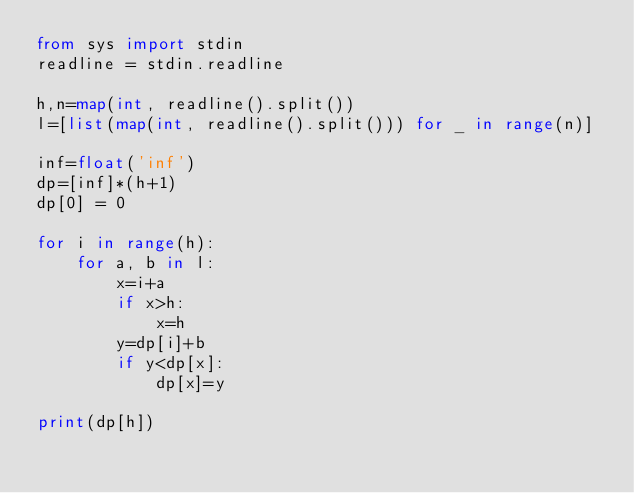Convert code to text. <code><loc_0><loc_0><loc_500><loc_500><_Python_>from sys import stdin
readline = stdin.readline

h,n=map(int, readline().split())
l=[list(map(int, readline().split())) for _ in range(n)]

inf=float('inf')
dp=[inf]*(h+1)
dp[0] = 0

for i in range(h):
    for a, b in l:
        x=i+a
        if x>h:
            x=h
        y=dp[i]+b
        if y<dp[x]:
            dp[x]=y

print(dp[h])</code> 